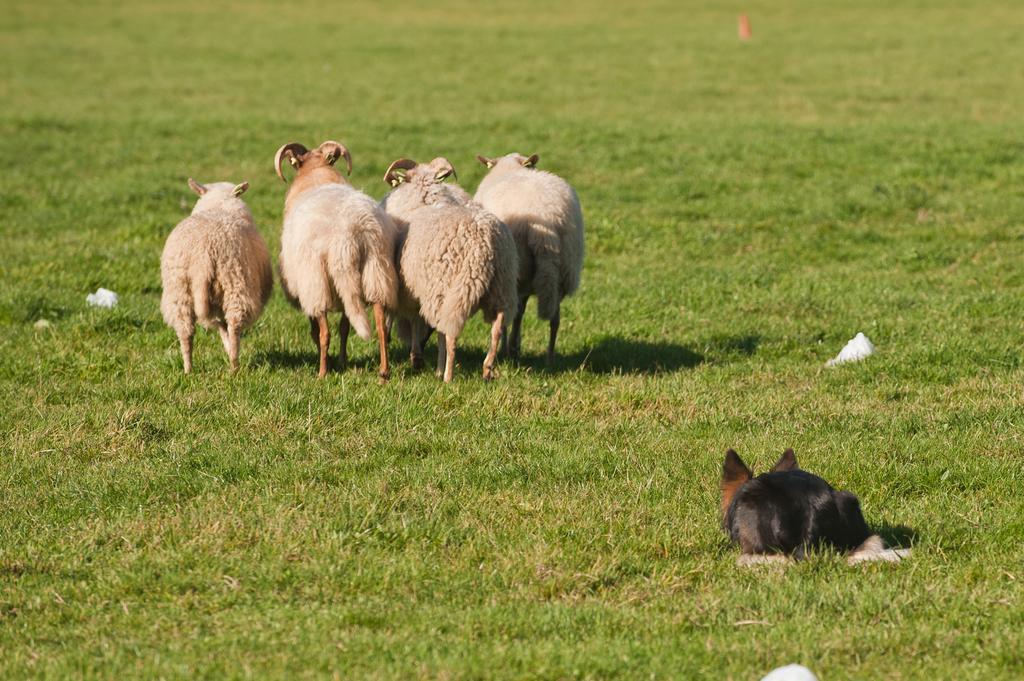Can you describe this image briefly? This image is taken outdoors. At the bottom of the image there is a ground with grass on it. In the middle of the image there are four sheep's on the ground. On the right side of the image there is an animal on the ground. 